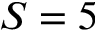<formula> <loc_0><loc_0><loc_500><loc_500>S = 5</formula> 